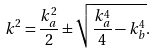<formula> <loc_0><loc_0><loc_500><loc_500>k ^ { 2 } = \frac { k _ { a } ^ { 2 } } { 2 } \pm \sqrt { \frac { k _ { a } ^ { 4 } } { 4 } - k _ { b } ^ { 4 } } .</formula> 